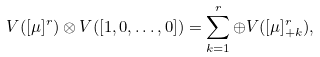Convert formula to latex. <formula><loc_0><loc_0><loc_500><loc_500>V ( [ \mu ] ^ { r } ) \otimes V ( [ 1 , 0 , \dots , 0 ] ) = \sum _ { k = 1 } ^ { r } \oplus V ( [ \mu ] _ { + k } ^ { r } ) ,</formula> 